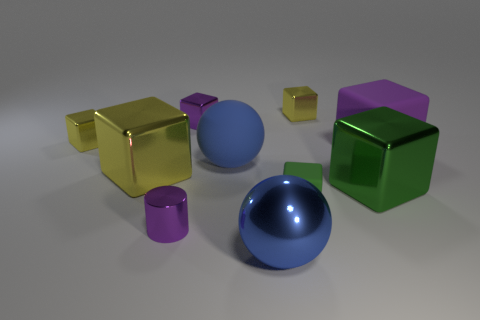How many yellow blocks must be subtracted to get 1 yellow blocks? 2 Subtract all green balls. How many yellow cubes are left? 3 Subtract all green cubes. How many cubes are left? 5 Subtract all small yellow blocks. How many blocks are left? 5 Subtract 1 cubes. How many cubes are left? 6 Subtract all green cubes. Subtract all green cylinders. How many cubes are left? 5 Subtract all balls. How many objects are left? 8 Subtract 0 gray blocks. How many objects are left? 10 Subtract all large blue rubber spheres. Subtract all yellow cubes. How many objects are left? 6 Add 2 blue matte spheres. How many blue matte spheres are left? 3 